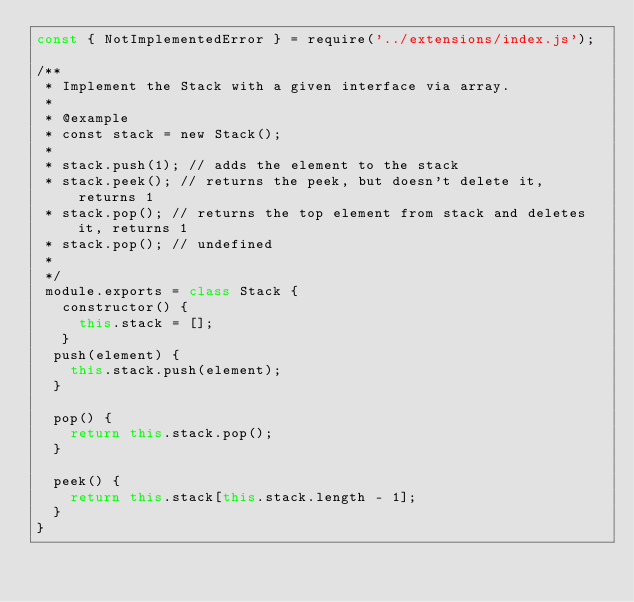Convert code to text. <code><loc_0><loc_0><loc_500><loc_500><_JavaScript_>const { NotImplementedError } = require('../extensions/index.js');

/**
 * Implement the Stack with a given interface via array.
 *
 * @example
 * const stack = new Stack();
 *
 * stack.push(1); // adds the element to the stack
 * stack.peek(); // returns the peek, but doesn't delete it, returns 1
 * stack.pop(); // returns the top element from stack and deletes it, returns 1
 * stack.pop(); // undefined
 *
 */
 module.exports = class Stack {
   constructor() {
     this.stack = [];
   }
  push(element) {
    this.stack.push(element);
  }

  pop() {
    return this.stack.pop();
  }

  peek() {
    return this.stack[this.stack.length - 1];
  }
}
</code> 